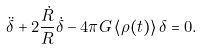<formula> <loc_0><loc_0><loc_500><loc_500>\ddot { \delta } + 2 \frac { \dot { R } } { R } \dot { \delta } - 4 \pi G \left \langle \rho ( t ) \right \rangle \delta = 0 .</formula> 